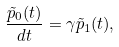Convert formula to latex. <formula><loc_0><loc_0><loc_500><loc_500>\frac { \tilde { p } _ { 0 } ( t ) } { d t } = \gamma \tilde { p } _ { 1 } ( t ) ,</formula> 